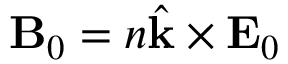Convert formula to latex. <formula><loc_0><loc_0><loc_500><loc_500>B _ { 0 } = n \hat { k } \times E _ { 0 }</formula> 